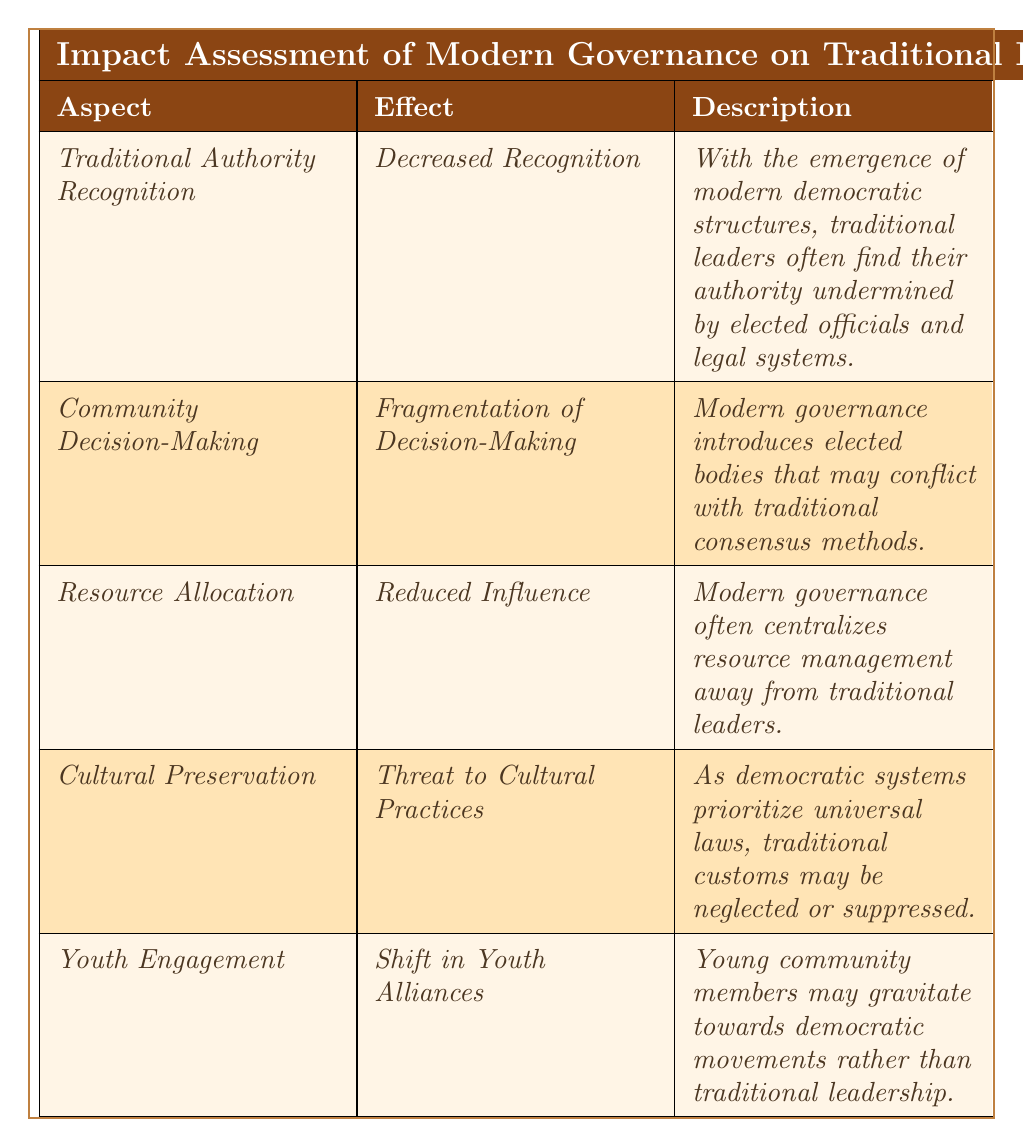What is the effect on traditional authority recognition? The table indicates that the effect is "Decreased Recognition" as modern governance emerges.
Answer: Decreased Recognition What is one example of reduced influence in resource allocation? In the table, it states that in Ghana, local chiefs report diminished control over land use compared to government agencies.
Answer: Local chiefs in Ghana What aspect conflicts with community decision-making? The table specifies that "Community Decision-Making" is impacted, leading to "Fragmentation of Decision-Making."
Answer: Community Decision-Making Which aspect is threatened by modern governance according to the table? The table shows that "Cultural Preservation" is threatened by modern governance, which prioritizes universal laws.
Answer: Cultural Preservation Are traditional leaders' roles still significant in decision-making? Based on the "Fragmentation of Decision-Making" description in the table, it suggests that traditional leaders' roles have diminished.
Answer: No What is the shift in youth alliances as per the findings? According to the table, young community members may shift their alliances towards democratic movements instead of traditional leadership.
Answer: Towards democratic movements What two aspects mention a decrease in influence or recognition? The table details "Traditional Authority Recognition" and "Resource Allocation," both indicating a decrease in influence or recognition.
Answer: Traditional Authority Recognition and Resource Allocation Identify the aspect that addresses the impact on traditional cultural practices. The table highlights "Cultural Preservation" as the aspect dealing with the impact on traditional cultural practices being neglected or suppressed.
Answer: Cultural Preservation Which country's elders have diminished authority due to elected representatives? The examples in the table indicate that in Kenya, the role of local elders has diminished as elected representatives gain authority.
Answer: Kenya Summarize the overall impact of modern governance on traditional leadership roles and structures. The table outlines that traditional leadership is facing decreased recognition, influence, fragmentation in decision-making, threats to cultural practices, and shifts in youth engagement.
Answer: Overall negative impact 